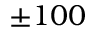Convert formula to latex. <formula><loc_0><loc_0><loc_500><loc_500>\pm 1 0 0</formula> 